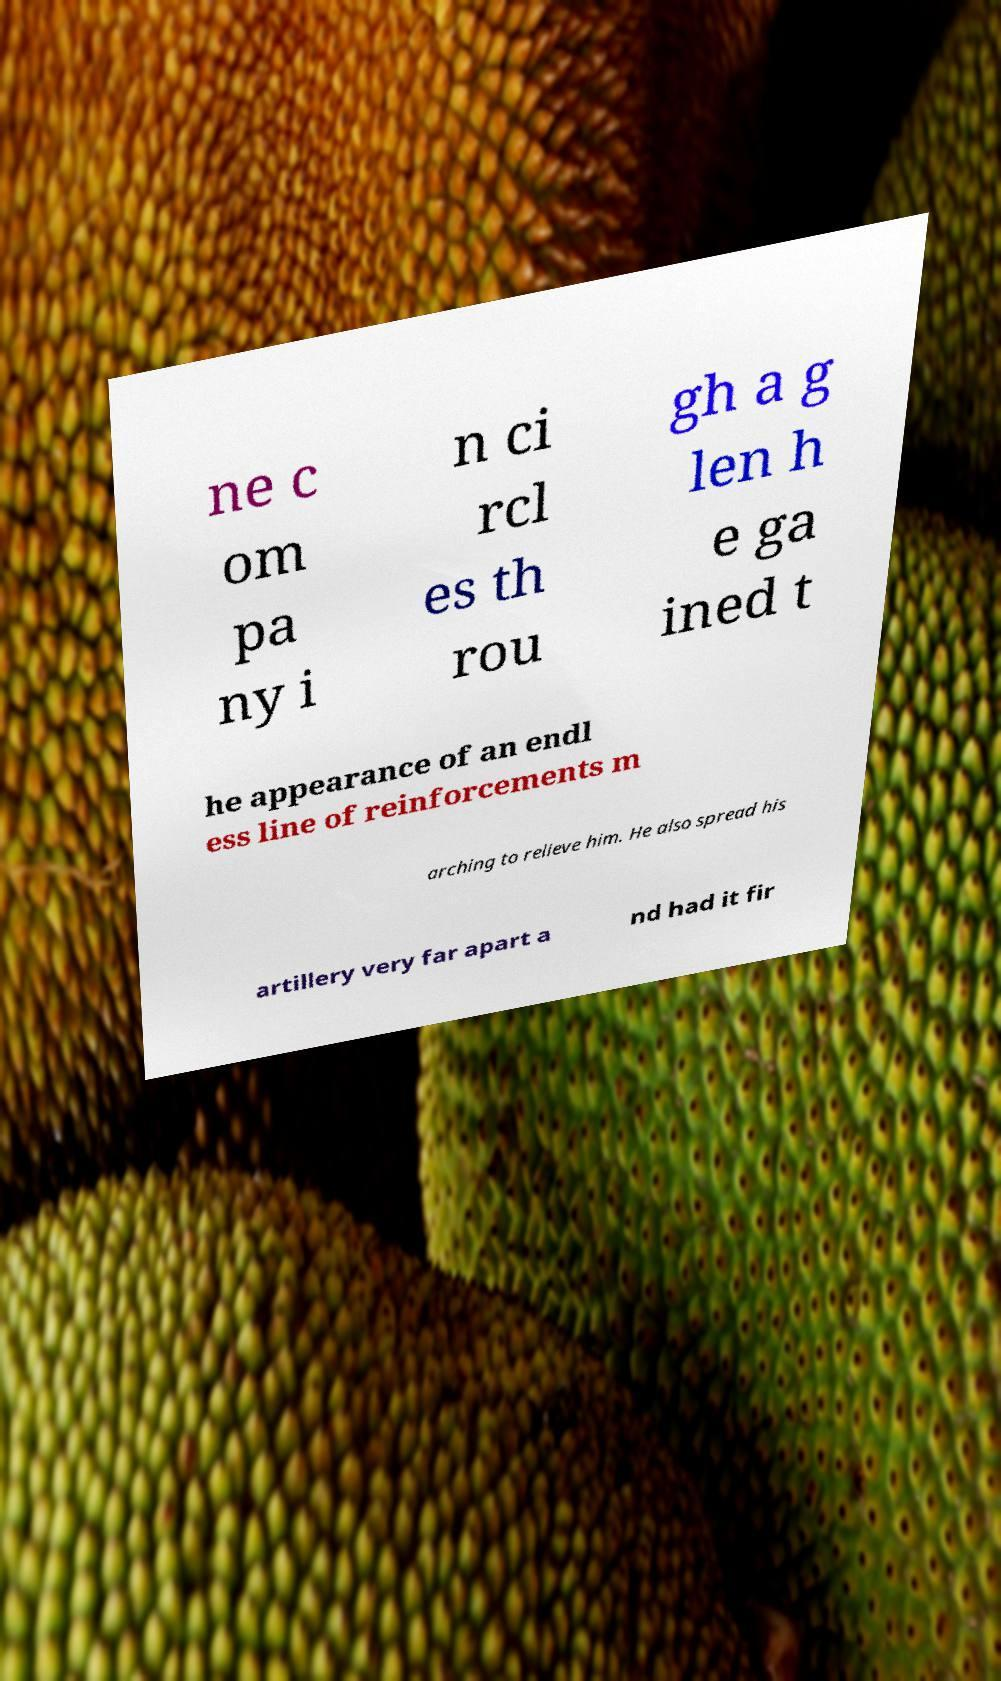There's text embedded in this image that I need extracted. Can you transcribe it verbatim? ne c om pa ny i n ci rcl es th rou gh a g len h e ga ined t he appearance of an endl ess line of reinforcements m arching to relieve him. He also spread his artillery very far apart a nd had it fir 